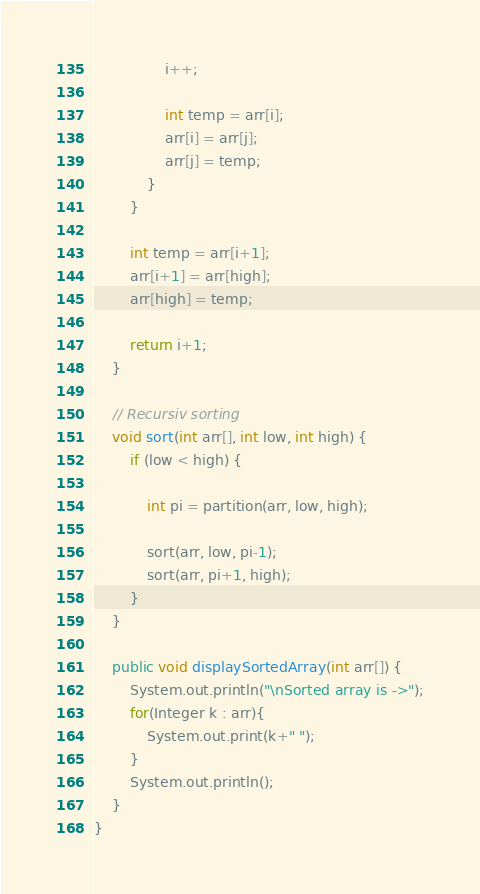<code> <loc_0><loc_0><loc_500><loc_500><_Java_>                i++;

                int temp = arr[i];
                arr[i] = arr[j];
                arr[j] = temp;
            }
        }

        int temp = arr[i+1];
        arr[i+1] = arr[high];
        arr[high] = temp;

        return i+1;
    }
    
    // Recursiv sorting 
    void sort(int arr[], int low, int high) {
        if (low < high) {

            int pi = partition(arr, low, high);

            sort(arr, low, pi-1);
            sort(arr, pi+1, high);
        }
    }

    public void displaySortedArray(int arr[]) {
        System.out.println("\nSorted array is ->");
        for(Integer k : arr){
            System.out.print(k+" ");
        }
        System.out.println();
    }
}</code> 